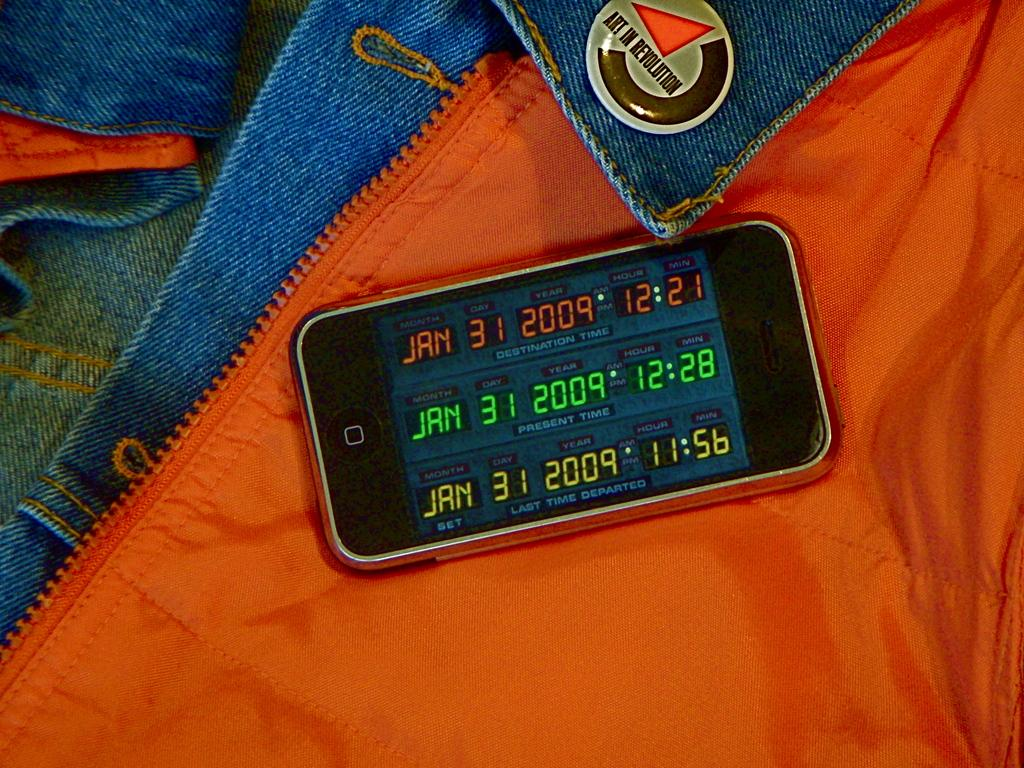What objects are present in the image? There are clothes and a mobile in the image. What is the purpose of the mobile? The mobile has text on its screen, which suggests it might be used for communication or displaying information. Can you describe the clothes in the image? Unfortunately, the facts provided do not give enough detail to describe the clothes in the image. What type of bell can be heard ringing in the image? There is no bell present in the image, and therefore no sound can be heard. What type of camp is visible in the image? There is no camp present in the image. 